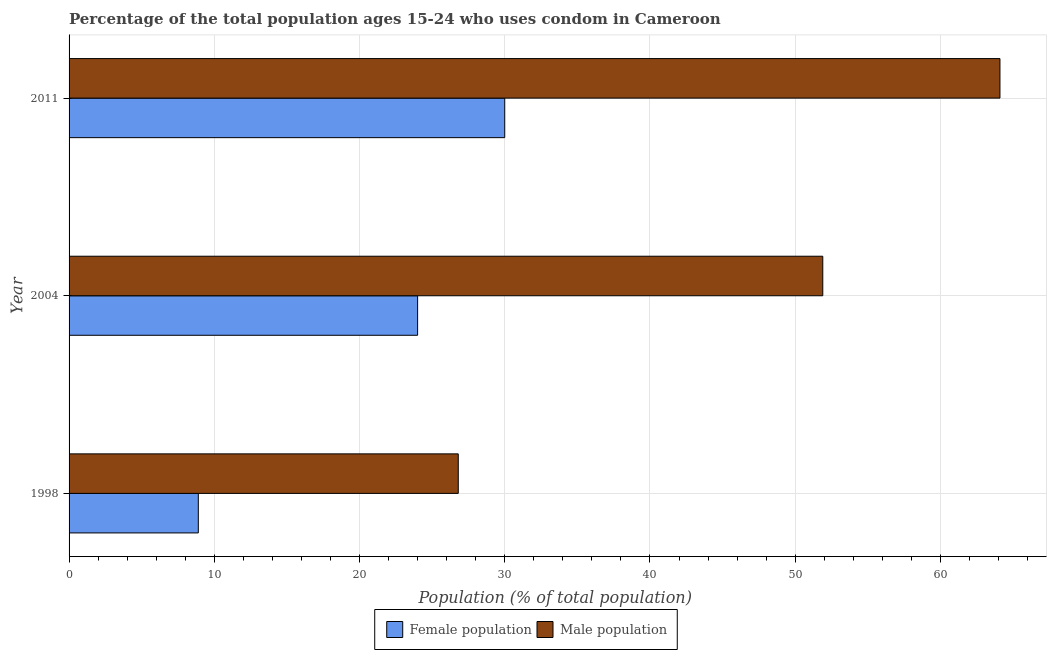Are the number of bars on each tick of the Y-axis equal?
Provide a short and direct response. Yes. What is the male population in 1998?
Your response must be concise. 26.8. Across all years, what is the maximum male population?
Keep it short and to the point. 64.1. Across all years, what is the minimum female population?
Your answer should be compact. 8.9. In which year was the male population maximum?
Provide a short and direct response. 2011. In which year was the male population minimum?
Make the answer very short. 1998. What is the total male population in the graph?
Offer a terse response. 142.8. What is the difference between the male population in 1998 and that in 2004?
Offer a terse response. -25.1. What is the difference between the male population in 1998 and the female population in 2004?
Make the answer very short. 2.8. What is the average female population per year?
Offer a terse response. 20.97. In the year 2004, what is the difference between the female population and male population?
Your response must be concise. -27.9. In how many years, is the male population greater than 44 %?
Your answer should be compact. 2. What is the ratio of the male population in 2004 to that in 2011?
Make the answer very short. 0.81. Is the female population in 1998 less than that in 2011?
Make the answer very short. Yes. What is the difference between the highest and the second highest female population?
Your response must be concise. 6. What is the difference between the highest and the lowest female population?
Provide a short and direct response. 21.1. Is the sum of the female population in 1998 and 2011 greater than the maximum male population across all years?
Ensure brevity in your answer.  No. What does the 1st bar from the top in 2004 represents?
Provide a succinct answer. Male population. What does the 2nd bar from the bottom in 1998 represents?
Provide a succinct answer. Male population. How many bars are there?
Ensure brevity in your answer.  6. Are all the bars in the graph horizontal?
Your response must be concise. Yes. What is the difference between two consecutive major ticks on the X-axis?
Your response must be concise. 10. Does the graph contain any zero values?
Keep it short and to the point. No. Does the graph contain grids?
Make the answer very short. Yes. Where does the legend appear in the graph?
Provide a short and direct response. Bottom center. What is the title of the graph?
Your answer should be compact. Percentage of the total population ages 15-24 who uses condom in Cameroon. Does "Long-term debt" appear as one of the legend labels in the graph?
Offer a very short reply. No. What is the label or title of the X-axis?
Offer a terse response. Population (% of total population) . What is the label or title of the Y-axis?
Provide a short and direct response. Year. What is the Population (% of total population)  in Female population in 1998?
Make the answer very short. 8.9. What is the Population (% of total population)  in Male population in 1998?
Make the answer very short. 26.8. What is the Population (% of total population)  of Male population in 2004?
Make the answer very short. 51.9. What is the Population (% of total population)  of Male population in 2011?
Give a very brief answer. 64.1. Across all years, what is the maximum Population (% of total population)  of Female population?
Give a very brief answer. 30. Across all years, what is the maximum Population (% of total population)  in Male population?
Your response must be concise. 64.1. Across all years, what is the minimum Population (% of total population)  of Male population?
Offer a terse response. 26.8. What is the total Population (% of total population)  in Female population in the graph?
Your response must be concise. 62.9. What is the total Population (% of total population)  in Male population in the graph?
Make the answer very short. 142.8. What is the difference between the Population (% of total population)  of Female population in 1998 and that in 2004?
Provide a short and direct response. -15.1. What is the difference between the Population (% of total population)  of Male population in 1998 and that in 2004?
Offer a terse response. -25.1. What is the difference between the Population (% of total population)  in Female population in 1998 and that in 2011?
Provide a short and direct response. -21.1. What is the difference between the Population (% of total population)  in Male population in 1998 and that in 2011?
Give a very brief answer. -37.3. What is the difference between the Population (% of total population)  in Female population in 2004 and that in 2011?
Offer a terse response. -6. What is the difference between the Population (% of total population)  in Male population in 2004 and that in 2011?
Offer a terse response. -12.2. What is the difference between the Population (% of total population)  in Female population in 1998 and the Population (% of total population)  in Male population in 2004?
Ensure brevity in your answer.  -43. What is the difference between the Population (% of total population)  of Female population in 1998 and the Population (% of total population)  of Male population in 2011?
Make the answer very short. -55.2. What is the difference between the Population (% of total population)  in Female population in 2004 and the Population (% of total population)  in Male population in 2011?
Make the answer very short. -40.1. What is the average Population (% of total population)  of Female population per year?
Your answer should be compact. 20.97. What is the average Population (% of total population)  of Male population per year?
Provide a succinct answer. 47.6. In the year 1998, what is the difference between the Population (% of total population)  in Female population and Population (% of total population)  in Male population?
Offer a very short reply. -17.9. In the year 2004, what is the difference between the Population (% of total population)  in Female population and Population (% of total population)  in Male population?
Offer a terse response. -27.9. In the year 2011, what is the difference between the Population (% of total population)  of Female population and Population (% of total population)  of Male population?
Provide a succinct answer. -34.1. What is the ratio of the Population (% of total population)  of Female population in 1998 to that in 2004?
Keep it short and to the point. 0.37. What is the ratio of the Population (% of total population)  of Male population in 1998 to that in 2004?
Keep it short and to the point. 0.52. What is the ratio of the Population (% of total population)  in Female population in 1998 to that in 2011?
Your response must be concise. 0.3. What is the ratio of the Population (% of total population)  in Male population in 1998 to that in 2011?
Provide a succinct answer. 0.42. What is the ratio of the Population (% of total population)  of Male population in 2004 to that in 2011?
Provide a succinct answer. 0.81. What is the difference between the highest and the second highest Population (% of total population)  of Female population?
Give a very brief answer. 6. What is the difference between the highest and the second highest Population (% of total population)  of Male population?
Your answer should be very brief. 12.2. What is the difference between the highest and the lowest Population (% of total population)  of Female population?
Provide a succinct answer. 21.1. What is the difference between the highest and the lowest Population (% of total population)  in Male population?
Offer a terse response. 37.3. 